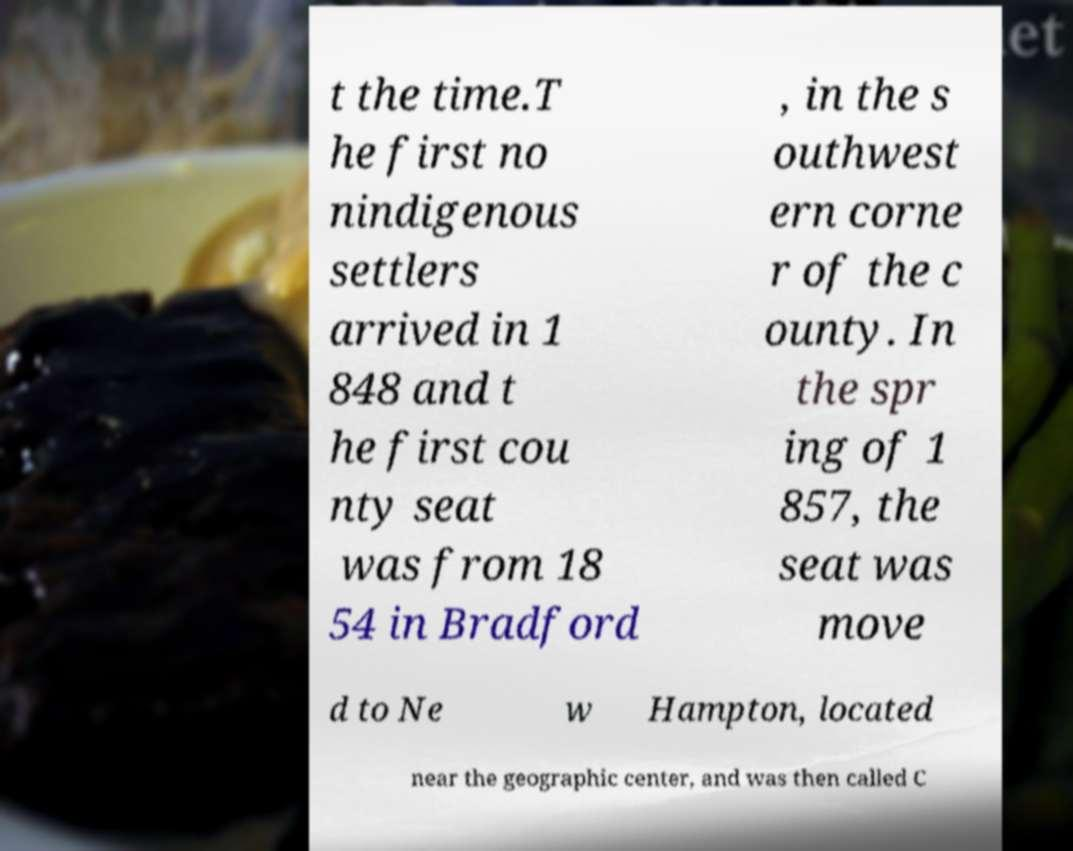Please read and relay the text visible in this image. What does it say? t the time.T he first no nindigenous settlers arrived in 1 848 and t he first cou nty seat was from 18 54 in Bradford , in the s outhwest ern corne r of the c ounty. In the spr ing of 1 857, the seat was move d to Ne w Hampton, located near the geographic center, and was then called C 